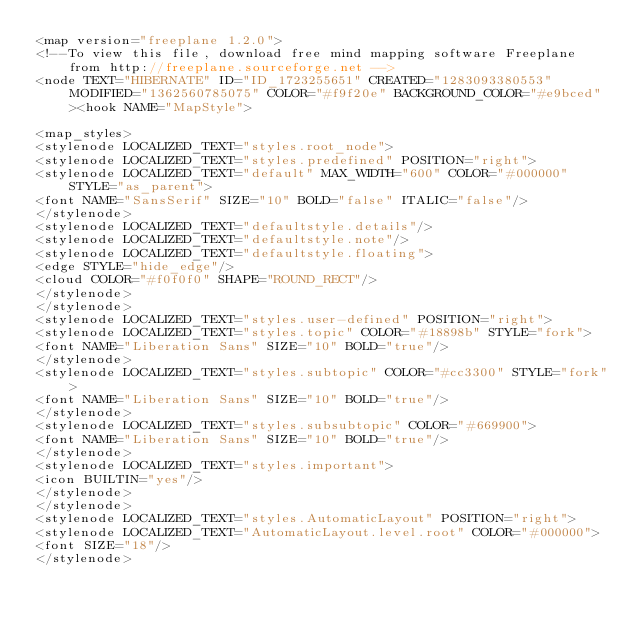Convert code to text. <code><loc_0><loc_0><loc_500><loc_500><_ObjectiveC_><map version="freeplane 1.2.0">
<!--To view this file, download free mind mapping software Freeplane from http://freeplane.sourceforge.net -->
<node TEXT="HIBERNATE" ID="ID_1723255651" CREATED="1283093380553" MODIFIED="1362560785075" COLOR="#f9f20e" BACKGROUND_COLOR="#e9bced"><hook NAME="MapStyle">

<map_styles>
<stylenode LOCALIZED_TEXT="styles.root_node">
<stylenode LOCALIZED_TEXT="styles.predefined" POSITION="right">
<stylenode LOCALIZED_TEXT="default" MAX_WIDTH="600" COLOR="#000000" STYLE="as_parent">
<font NAME="SansSerif" SIZE="10" BOLD="false" ITALIC="false"/>
</stylenode>
<stylenode LOCALIZED_TEXT="defaultstyle.details"/>
<stylenode LOCALIZED_TEXT="defaultstyle.note"/>
<stylenode LOCALIZED_TEXT="defaultstyle.floating">
<edge STYLE="hide_edge"/>
<cloud COLOR="#f0f0f0" SHAPE="ROUND_RECT"/>
</stylenode>
</stylenode>
<stylenode LOCALIZED_TEXT="styles.user-defined" POSITION="right">
<stylenode LOCALIZED_TEXT="styles.topic" COLOR="#18898b" STYLE="fork">
<font NAME="Liberation Sans" SIZE="10" BOLD="true"/>
</stylenode>
<stylenode LOCALIZED_TEXT="styles.subtopic" COLOR="#cc3300" STYLE="fork">
<font NAME="Liberation Sans" SIZE="10" BOLD="true"/>
</stylenode>
<stylenode LOCALIZED_TEXT="styles.subsubtopic" COLOR="#669900">
<font NAME="Liberation Sans" SIZE="10" BOLD="true"/>
</stylenode>
<stylenode LOCALIZED_TEXT="styles.important">
<icon BUILTIN="yes"/>
</stylenode>
</stylenode>
<stylenode LOCALIZED_TEXT="styles.AutomaticLayout" POSITION="right">
<stylenode LOCALIZED_TEXT="AutomaticLayout.level.root" COLOR="#000000">
<font SIZE="18"/>
</stylenode></code> 